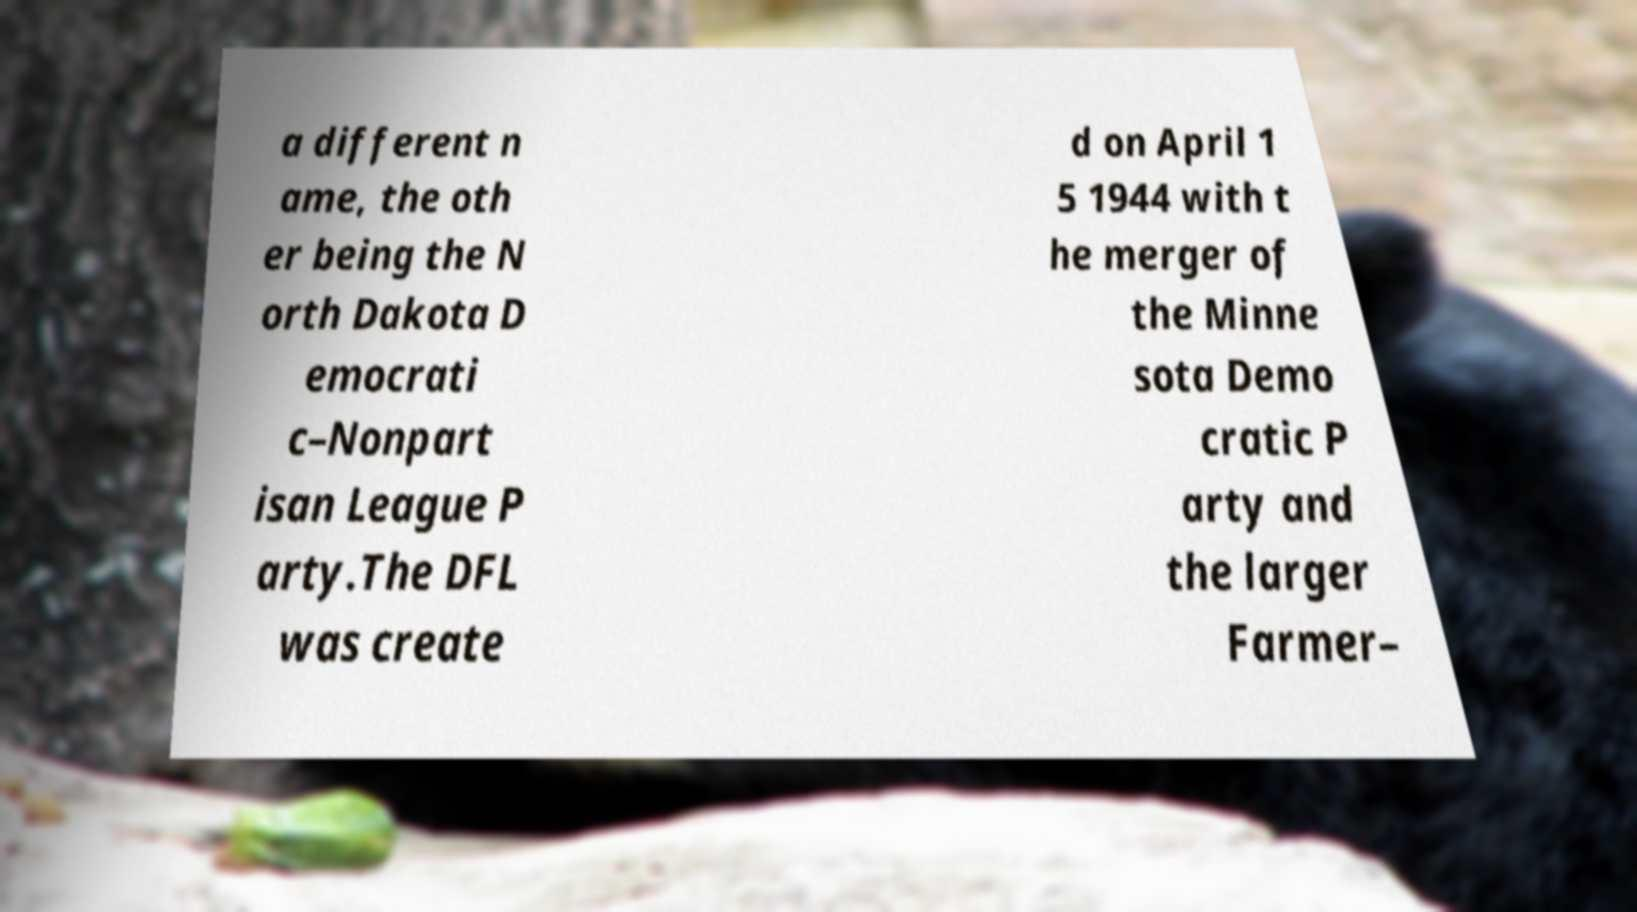Could you extract and type out the text from this image? a different n ame, the oth er being the N orth Dakota D emocrati c–Nonpart isan League P arty.The DFL was create d on April 1 5 1944 with t he merger of the Minne sota Demo cratic P arty and the larger Farmer– 